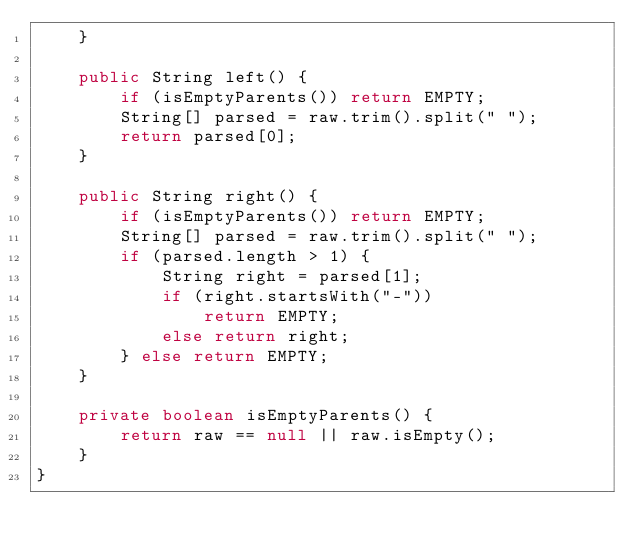Convert code to text. <code><loc_0><loc_0><loc_500><loc_500><_Java_>    }

    public String left() {
        if (isEmptyParents()) return EMPTY;
        String[] parsed = raw.trim().split(" ");
        return parsed[0];
    }

    public String right() {
        if (isEmptyParents()) return EMPTY;
        String[] parsed = raw.trim().split(" ");
        if (parsed.length > 1) {
            String right = parsed[1];
            if (right.startsWith("-"))
                return EMPTY;
            else return right;
        } else return EMPTY;
    }

    private boolean isEmptyParents() {
        return raw == null || raw.isEmpty();
    }
}
</code> 